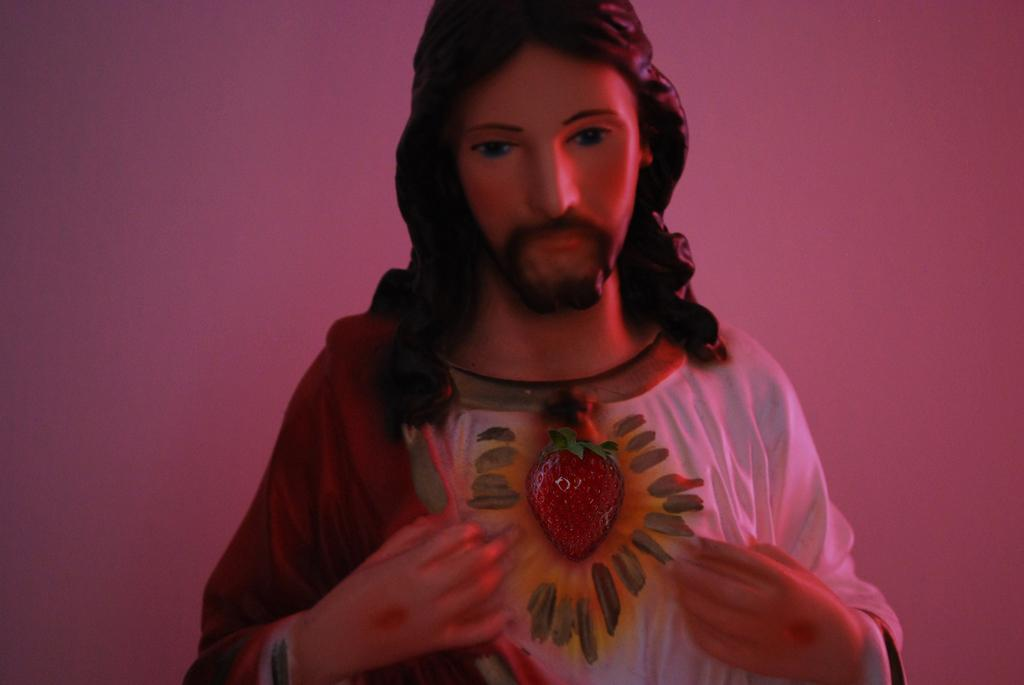What is the main subject of the image? There is a statue of Jesus Christ in the image. What can be observed about the background of the image? The background of the image is pink in color. How many dogs are holding umbrellas in the image? There are no dogs or umbrellas present in the image. 